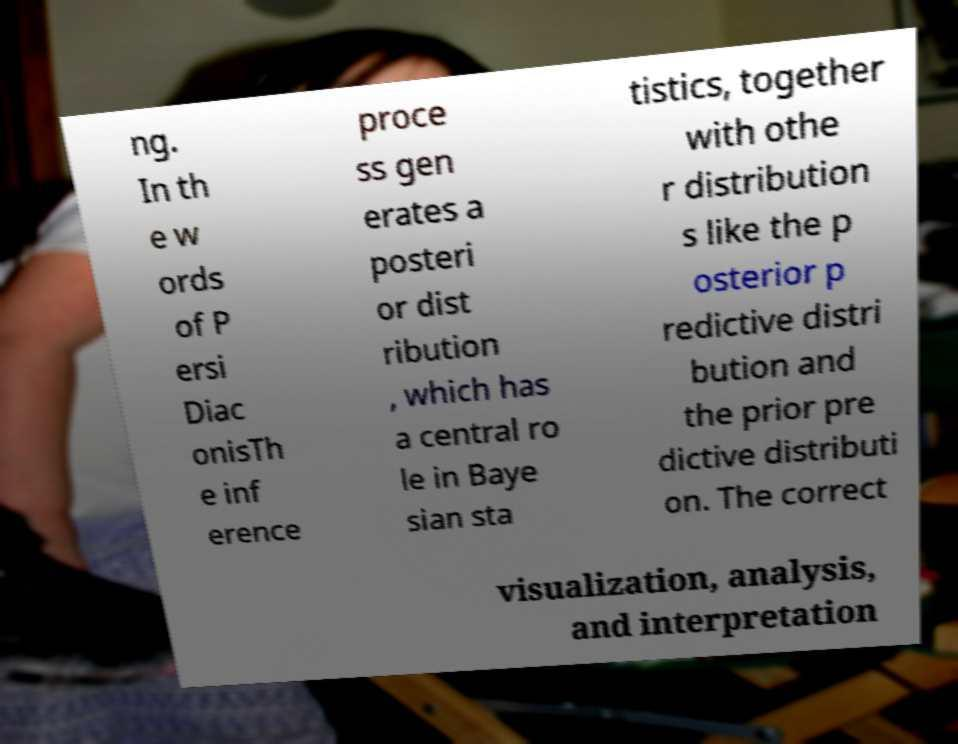Could you assist in decoding the text presented in this image and type it out clearly? ng. In th e w ords of P ersi Diac onisTh e inf erence proce ss gen erates a posteri or dist ribution , which has a central ro le in Baye sian sta tistics, together with othe r distribution s like the p osterior p redictive distri bution and the prior pre dictive distributi on. The correct visualization, analysis, and interpretation 